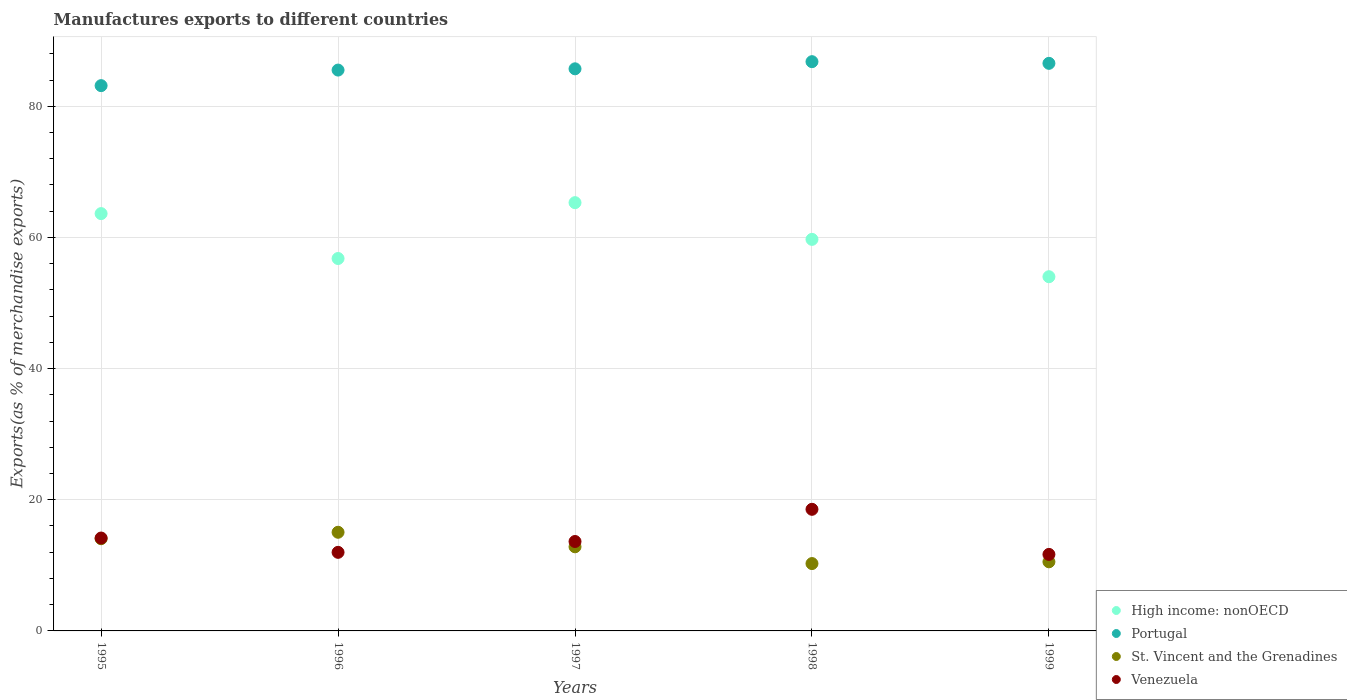How many different coloured dotlines are there?
Keep it short and to the point. 4. What is the percentage of exports to different countries in Portugal in 1998?
Give a very brief answer. 86.8. Across all years, what is the maximum percentage of exports to different countries in Venezuela?
Your answer should be compact. 18.54. Across all years, what is the minimum percentage of exports to different countries in St. Vincent and the Grenadines?
Your answer should be very brief. 10.27. In which year was the percentage of exports to different countries in Venezuela minimum?
Provide a short and direct response. 1999. What is the total percentage of exports to different countries in St. Vincent and the Grenadines in the graph?
Give a very brief answer. 62.73. What is the difference between the percentage of exports to different countries in Portugal in 1995 and that in 1996?
Provide a short and direct response. -2.37. What is the difference between the percentage of exports to different countries in St. Vincent and the Grenadines in 1995 and the percentage of exports to different countries in Portugal in 1996?
Provide a short and direct response. -71.46. What is the average percentage of exports to different countries in High income: nonOECD per year?
Offer a very short reply. 59.88. In the year 1998, what is the difference between the percentage of exports to different countries in Venezuela and percentage of exports to different countries in St. Vincent and the Grenadines?
Provide a succinct answer. 8.27. In how many years, is the percentage of exports to different countries in St. Vincent and the Grenadines greater than 40 %?
Make the answer very short. 0. What is the ratio of the percentage of exports to different countries in High income: nonOECD in 1995 to that in 1998?
Offer a very short reply. 1.07. Is the percentage of exports to different countries in Portugal in 1996 less than that in 1999?
Provide a short and direct response. Yes. What is the difference between the highest and the second highest percentage of exports to different countries in Portugal?
Your response must be concise. 0.26. What is the difference between the highest and the lowest percentage of exports to different countries in High income: nonOECD?
Your answer should be compact. 11.29. In how many years, is the percentage of exports to different countries in St. Vincent and the Grenadines greater than the average percentage of exports to different countries in St. Vincent and the Grenadines taken over all years?
Provide a short and direct response. 3. Is the sum of the percentage of exports to different countries in Portugal in 1996 and 1997 greater than the maximum percentage of exports to different countries in High income: nonOECD across all years?
Your response must be concise. Yes. Is it the case that in every year, the sum of the percentage of exports to different countries in Venezuela and percentage of exports to different countries in St. Vincent and the Grenadines  is greater than the percentage of exports to different countries in Portugal?
Your answer should be compact. No. Does the percentage of exports to different countries in Venezuela monotonically increase over the years?
Make the answer very short. No. Is the percentage of exports to different countries in St. Vincent and the Grenadines strictly less than the percentage of exports to different countries in Portugal over the years?
Your answer should be compact. Yes. How many dotlines are there?
Make the answer very short. 4. How many years are there in the graph?
Your answer should be very brief. 5. What is the title of the graph?
Offer a very short reply. Manufactures exports to different countries. Does "Myanmar" appear as one of the legend labels in the graph?
Ensure brevity in your answer.  No. What is the label or title of the X-axis?
Provide a succinct answer. Years. What is the label or title of the Y-axis?
Ensure brevity in your answer.  Exports(as % of merchandise exports). What is the Exports(as % of merchandise exports) of High income: nonOECD in 1995?
Ensure brevity in your answer.  63.63. What is the Exports(as % of merchandise exports) of Portugal in 1995?
Provide a succinct answer. 83.14. What is the Exports(as % of merchandise exports) of St. Vincent and the Grenadines in 1995?
Make the answer very short. 14.06. What is the Exports(as % of merchandise exports) in Venezuela in 1995?
Your response must be concise. 14.16. What is the Exports(as % of merchandise exports) of High income: nonOECD in 1996?
Offer a terse response. 56.78. What is the Exports(as % of merchandise exports) of Portugal in 1996?
Offer a terse response. 85.51. What is the Exports(as % of merchandise exports) of St. Vincent and the Grenadines in 1996?
Ensure brevity in your answer.  15.04. What is the Exports(as % of merchandise exports) in Venezuela in 1996?
Ensure brevity in your answer.  11.98. What is the Exports(as % of merchandise exports) of High income: nonOECD in 1997?
Your response must be concise. 65.3. What is the Exports(as % of merchandise exports) in Portugal in 1997?
Your answer should be compact. 85.71. What is the Exports(as % of merchandise exports) in St. Vincent and the Grenadines in 1997?
Provide a succinct answer. 12.83. What is the Exports(as % of merchandise exports) of Venezuela in 1997?
Keep it short and to the point. 13.64. What is the Exports(as % of merchandise exports) of High income: nonOECD in 1998?
Offer a terse response. 59.7. What is the Exports(as % of merchandise exports) of Portugal in 1998?
Provide a succinct answer. 86.8. What is the Exports(as % of merchandise exports) in St. Vincent and the Grenadines in 1998?
Give a very brief answer. 10.27. What is the Exports(as % of merchandise exports) of Venezuela in 1998?
Keep it short and to the point. 18.54. What is the Exports(as % of merchandise exports) of High income: nonOECD in 1999?
Offer a very short reply. 54.01. What is the Exports(as % of merchandise exports) of Portugal in 1999?
Provide a succinct answer. 86.54. What is the Exports(as % of merchandise exports) in St. Vincent and the Grenadines in 1999?
Offer a very short reply. 10.54. What is the Exports(as % of merchandise exports) of Venezuela in 1999?
Make the answer very short. 11.67. Across all years, what is the maximum Exports(as % of merchandise exports) in High income: nonOECD?
Keep it short and to the point. 65.3. Across all years, what is the maximum Exports(as % of merchandise exports) in Portugal?
Ensure brevity in your answer.  86.8. Across all years, what is the maximum Exports(as % of merchandise exports) of St. Vincent and the Grenadines?
Offer a very short reply. 15.04. Across all years, what is the maximum Exports(as % of merchandise exports) of Venezuela?
Your answer should be compact. 18.54. Across all years, what is the minimum Exports(as % of merchandise exports) of High income: nonOECD?
Keep it short and to the point. 54.01. Across all years, what is the minimum Exports(as % of merchandise exports) of Portugal?
Your response must be concise. 83.14. Across all years, what is the minimum Exports(as % of merchandise exports) in St. Vincent and the Grenadines?
Make the answer very short. 10.27. Across all years, what is the minimum Exports(as % of merchandise exports) in Venezuela?
Keep it short and to the point. 11.67. What is the total Exports(as % of merchandise exports) of High income: nonOECD in the graph?
Give a very brief answer. 299.42. What is the total Exports(as % of merchandise exports) of Portugal in the graph?
Make the answer very short. 427.7. What is the total Exports(as % of merchandise exports) of St. Vincent and the Grenadines in the graph?
Provide a succinct answer. 62.73. What is the total Exports(as % of merchandise exports) of Venezuela in the graph?
Offer a very short reply. 69.99. What is the difference between the Exports(as % of merchandise exports) of High income: nonOECD in 1995 and that in 1996?
Your response must be concise. 6.85. What is the difference between the Exports(as % of merchandise exports) of Portugal in 1995 and that in 1996?
Make the answer very short. -2.37. What is the difference between the Exports(as % of merchandise exports) of St. Vincent and the Grenadines in 1995 and that in 1996?
Ensure brevity in your answer.  -0.98. What is the difference between the Exports(as % of merchandise exports) in Venezuela in 1995 and that in 1996?
Give a very brief answer. 2.18. What is the difference between the Exports(as % of merchandise exports) in High income: nonOECD in 1995 and that in 1997?
Offer a terse response. -1.67. What is the difference between the Exports(as % of merchandise exports) of Portugal in 1995 and that in 1997?
Your answer should be very brief. -2.56. What is the difference between the Exports(as % of merchandise exports) of St. Vincent and the Grenadines in 1995 and that in 1997?
Keep it short and to the point. 1.23. What is the difference between the Exports(as % of merchandise exports) in Venezuela in 1995 and that in 1997?
Offer a terse response. 0.53. What is the difference between the Exports(as % of merchandise exports) of High income: nonOECD in 1995 and that in 1998?
Offer a terse response. 3.93. What is the difference between the Exports(as % of merchandise exports) in Portugal in 1995 and that in 1998?
Ensure brevity in your answer.  -3.65. What is the difference between the Exports(as % of merchandise exports) in St. Vincent and the Grenadines in 1995 and that in 1998?
Provide a succinct answer. 3.79. What is the difference between the Exports(as % of merchandise exports) in Venezuela in 1995 and that in 1998?
Your answer should be very brief. -4.38. What is the difference between the Exports(as % of merchandise exports) of High income: nonOECD in 1995 and that in 1999?
Offer a very short reply. 9.62. What is the difference between the Exports(as % of merchandise exports) of Portugal in 1995 and that in 1999?
Keep it short and to the point. -3.4. What is the difference between the Exports(as % of merchandise exports) of St. Vincent and the Grenadines in 1995 and that in 1999?
Your response must be concise. 3.52. What is the difference between the Exports(as % of merchandise exports) of Venezuela in 1995 and that in 1999?
Provide a succinct answer. 2.5. What is the difference between the Exports(as % of merchandise exports) of High income: nonOECD in 1996 and that in 1997?
Keep it short and to the point. -8.51. What is the difference between the Exports(as % of merchandise exports) in Portugal in 1996 and that in 1997?
Keep it short and to the point. -0.19. What is the difference between the Exports(as % of merchandise exports) in St. Vincent and the Grenadines in 1996 and that in 1997?
Ensure brevity in your answer.  2.22. What is the difference between the Exports(as % of merchandise exports) in Venezuela in 1996 and that in 1997?
Ensure brevity in your answer.  -1.65. What is the difference between the Exports(as % of merchandise exports) of High income: nonOECD in 1996 and that in 1998?
Keep it short and to the point. -2.92. What is the difference between the Exports(as % of merchandise exports) in Portugal in 1996 and that in 1998?
Your answer should be very brief. -1.28. What is the difference between the Exports(as % of merchandise exports) in St. Vincent and the Grenadines in 1996 and that in 1998?
Your response must be concise. 4.77. What is the difference between the Exports(as % of merchandise exports) in Venezuela in 1996 and that in 1998?
Your answer should be very brief. -6.56. What is the difference between the Exports(as % of merchandise exports) in High income: nonOECD in 1996 and that in 1999?
Your answer should be compact. 2.78. What is the difference between the Exports(as % of merchandise exports) in Portugal in 1996 and that in 1999?
Ensure brevity in your answer.  -1.03. What is the difference between the Exports(as % of merchandise exports) of St. Vincent and the Grenadines in 1996 and that in 1999?
Keep it short and to the point. 4.51. What is the difference between the Exports(as % of merchandise exports) in Venezuela in 1996 and that in 1999?
Offer a terse response. 0.31. What is the difference between the Exports(as % of merchandise exports) of High income: nonOECD in 1997 and that in 1998?
Make the answer very short. 5.6. What is the difference between the Exports(as % of merchandise exports) of Portugal in 1997 and that in 1998?
Keep it short and to the point. -1.09. What is the difference between the Exports(as % of merchandise exports) in St. Vincent and the Grenadines in 1997 and that in 1998?
Ensure brevity in your answer.  2.56. What is the difference between the Exports(as % of merchandise exports) in Venezuela in 1997 and that in 1998?
Give a very brief answer. -4.91. What is the difference between the Exports(as % of merchandise exports) in High income: nonOECD in 1997 and that in 1999?
Your answer should be compact. 11.29. What is the difference between the Exports(as % of merchandise exports) in Portugal in 1997 and that in 1999?
Offer a very short reply. -0.83. What is the difference between the Exports(as % of merchandise exports) of St. Vincent and the Grenadines in 1997 and that in 1999?
Provide a short and direct response. 2.29. What is the difference between the Exports(as % of merchandise exports) of Venezuela in 1997 and that in 1999?
Give a very brief answer. 1.97. What is the difference between the Exports(as % of merchandise exports) of High income: nonOECD in 1998 and that in 1999?
Make the answer very short. 5.69. What is the difference between the Exports(as % of merchandise exports) of Portugal in 1998 and that in 1999?
Ensure brevity in your answer.  0.26. What is the difference between the Exports(as % of merchandise exports) of St. Vincent and the Grenadines in 1998 and that in 1999?
Provide a succinct answer. -0.27. What is the difference between the Exports(as % of merchandise exports) in Venezuela in 1998 and that in 1999?
Your response must be concise. 6.88. What is the difference between the Exports(as % of merchandise exports) of High income: nonOECD in 1995 and the Exports(as % of merchandise exports) of Portugal in 1996?
Offer a terse response. -21.88. What is the difference between the Exports(as % of merchandise exports) in High income: nonOECD in 1995 and the Exports(as % of merchandise exports) in St. Vincent and the Grenadines in 1996?
Your answer should be compact. 48.59. What is the difference between the Exports(as % of merchandise exports) of High income: nonOECD in 1995 and the Exports(as % of merchandise exports) of Venezuela in 1996?
Provide a short and direct response. 51.65. What is the difference between the Exports(as % of merchandise exports) in Portugal in 1995 and the Exports(as % of merchandise exports) in St. Vincent and the Grenadines in 1996?
Offer a very short reply. 68.1. What is the difference between the Exports(as % of merchandise exports) of Portugal in 1995 and the Exports(as % of merchandise exports) of Venezuela in 1996?
Make the answer very short. 71.16. What is the difference between the Exports(as % of merchandise exports) of St. Vincent and the Grenadines in 1995 and the Exports(as % of merchandise exports) of Venezuela in 1996?
Give a very brief answer. 2.08. What is the difference between the Exports(as % of merchandise exports) in High income: nonOECD in 1995 and the Exports(as % of merchandise exports) in Portugal in 1997?
Offer a very short reply. -22.08. What is the difference between the Exports(as % of merchandise exports) of High income: nonOECD in 1995 and the Exports(as % of merchandise exports) of St. Vincent and the Grenadines in 1997?
Provide a short and direct response. 50.8. What is the difference between the Exports(as % of merchandise exports) in High income: nonOECD in 1995 and the Exports(as % of merchandise exports) in Venezuela in 1997?
Your answer should be very brief. 49.99. What is the difference between the Exports(as % of merchandise exports) in Portugal in 1995 and the Exports(as % of merchandise exports) in St. Vincent and the Grenadines in 1997?
Offer a very short reply. 70.32. What is the difference between the Exports(as % of merchandise exports) in Portugal in 1995 and the Exports(as % of merchandise exports) in Venezuela in 1997?
Make the answer very short. 69.51. What is the difference between the Exports(as % of merchandise exports) in St. Vincent and the Grenadines in 1995 and the Exports(as % of merchandise exports) in Venezuela in 1997?
Your answer should be compact. 0.42. What is the difference between the Exports(as % of merchandise exports) in High income: nonOECD in 1995 and the Exports(as % of merchandise exports) in Portugal in 1998?
Keep it short and to the point. -23.17. What is the difference between the Exports(as % of merchandise exports) of High income: nonOECD in 1995 and the Exports(as % of merchandise exports) of St. Vincent and the Grenadines in 1998?
Provide a succinct answer. 53.36. What is the difference between the Exports(as % of merchandise exports) of High income: nonOECD in 1995 and the Exports(as % of merchandise exports) of Venezuela in 1998?
Make the answer very short. 45.09. What is the difference between the Exports(as % of merchandise exports) of Portugal in 1995 and the Exports(as % of merchandise exports) of St. Vincent and the Grenadines in 1998?
Keep it short and to the point. 72.87. What is the difference between the Exports(as % of merchandise exports) in Portugal in 1995 and the Exports(as % of merchandise exports) in Venezuela in 1998?
Keep it short and to the point. 64.6. What is the difference between the Exports(as % of merchandise exports) in St. Vincent and the Grenadines in 1995 and the Exports(as % of merchandise exports) in Venezuela in 1998?
Offer a terse response. -4.49. What is the difference between the Exports(as % of merchandise exports) in High income: nonOECD in 1995 and the Exports(as % of merchandise exports) in Portugal in 1999?
Give a very brief answer. -22.91. What is the difference between the Exports(as % of merchandise exports) in High income: nonOECD in 1995 and the Exports(as % of merchandise exports) in St. Vincent and the Grenadines in 1999?
Offer a very short reply. 53.09. What is the difference between the Exports(as % of merchandise exports) of High income: nonOECD in 1995 and the Exports(as % of merchandise exports) of Venezuela in 1999?
Your answer should be very brief. 51.96. What is the difference between the Exports(as % of merchandise exports) of Portugal in 1995 and the Exports(as % of merchandise exports) of St. Vincent and the Grenadines in 1999?
Keep it short and to the point. 72.6. What is the difference between the Exports(as % of merchandise exports) of Portugal in 1995 and the Exports(as % of merchandise exports) of Venezuela in 1999?
Your response must be concise. 71.47. What is the difference between the Exports(as % of merchandise exports) in St. Vincent and the Grenadines in 1995 and the Exports(as % of merchandise exports) in Venezuela in 1999?
Keep it short and to the point. 2.39. What is the difference between the Exports(as % of merchandise exports) of High income: nonOECD in 1996 and the Exports(as % of merchandise exports) of Portugal in 1997?
Make the answer very short. -28.92. What is the difference between the Exports(as % of merchandise exports) of High income: nonOECD in 1996 and the Exports(as % of merchandise exports) of St. Vincent and the Grenadines in 1997?
Offer a terse response. 43.96. What is the difference between the Exports(as % of merchandise exports) of High income: nonOECD in 1996 and the Exports(as % of merchandise exports) of Venezuela in 1997?
Keep it short and to the point. 43.15. What is the difference between the Exports(as % of merchandise exports) in Portugal in 1996 and the Exports(as % of merchandise exports) in St. Vincent and the Grenadines in 1997?
Offer a terse response. 72.69. What is the difference between the Exports(as % of merchandise exports) in Portugal in 1996 and the Exports(as % of merchandise exports) in Venezuela in 1997?
Your answer should be compact. 71.88. What is the difference between the Exports(as % of merchandise exports) of St. Vincent and the Grenadines in 1996 and the Exports(as % of merchandise exports) of Venezuela in 1997?
Give a very brief answer. 1.41. What is the difference between the Exports(as % of merchandise exports) of High income: nonOECD in 1996 and the Exports(as % of merchandise exports) of Portugal in 1998?
Keep it short and to the point. -30.01. What is the difference between the Exports(as % of merchandise exports) in High income: nonOECD in 1996 and the Exports(as % of merchandise exports) in St. Vincent and the Grenadines in 1998?
Provide a short and direct response. 46.51. What is the difference between the Exports(as % of merchandise exports) of High income: nonOECD in 1996 and the Exports(as % of merchandise exports) of Venezuela in 1998?
Offer a terse response. 38.24. What is the difference between the Exports(as % of merchandise exports) of Portugal in 1996 and the Exports(as % of merchandise exports) of St. Vincent and the Grenadines in 1998?
Offer a terse response. 75.25. What is the difference between the Exports(as % of merchandise exports) of Portugal in 1996 and the Exports(as % of merchandise exports) of Venezuela in 1998?
Offer a terse response. 66.97. What is the difference between the Exports(as % of merchandise exports) in St. Vincent and the Grenadines in 1996 and the Exports(as % of merchandise exports) in Venezuela in 1998?
Offer a terse response. -3.5. What is the difference between the Exports(as % of merchandise exports) of High income: nonOECD in 1996 and the Exports(as % of merchandise exports) of Portugal in 1999?
Make the answer very short. -29.76. What is the difference between the Exports(as % of merchandise exports) of High income: nonOECD in 1996 and the Exports(as % of merchandise exports) of St. Vincent and the Grenadines in 1999?
Your answer should be compact. 46.25. What is the difference between the Exports(as % of merchandise exports) in High income: nonOECD in 1996 and the Exports(as % of merchandise exports) in Venezuela in 1999?
Your response must be concise. 45.12. What is the difference between the Exports(as % of merchandise exports) of Portugal in 1996 and the Exports(as % of merchandise exports) of St. Vincent and the Grenadines in 1999?
Your response must be concise. 74.98. What is the difference between the Exports(as % of merchandise exports) in Portugal in 1996 and the Exports(as % of merchandise exports) in Venezuela in 1999?
Keep it short and to the point. 73.85. What is the difference between the Exports(as % of merchandise exports) of St. Vincent and the Grenadines in 1996 and the Exports(as % of merchandise exports) of Venezuela in 1999?
Provide a succinct answer. 3.37. What is the difference between the Exports(as % of merchandise exports) in High income: nonOECD in 1997 and the Exports(as % of merchandise exports) in Portugal in 1998?
Give a very brief answer. -21.5. What is the difference between the Exports(as % of merchandise exports) in High income: nonOECD in 1997 and the Exports(as % of merchandise exports) in St. Vincent and the Grenadines in 1998?
Make the answer very short. 55.03. What is the difference between the Exports(as % of merchandise exports) in High income: nonOECD in 1997 and the Exports(as % of merchandise exports) in Venezuela in 1998?
Provide a short and direct response. 46.76. What is the difference between the Exports(as % of merchandise exports) of Portugal in 1997 and the Exports(as % of merchandise exports) of St. Vincent and the Grenadines in 1998?
Ensure brevity in your answer.  75.44. What is the difference between the Exports(as % of merchandise exports) in Portugal in 1997 and the Exports(as % of merchandise exports) in Venezuela in 1998?
Offer a terse response. 67.16. What is the difference between the Exports(as % of merchandise exports) in St. Vincent and the Grenadines in 1997 and the Exports(as % of merchandise exports) in Venezuela in 1998?
Your response must be concise. -5.72. What is the difference between the Exports(as % of merchandise exports) in High income: nonOECD in 1997 and the Exports(as % of merchandise exports) in Portugal in 1999?
Your answer should be compact. -21.24. What is the difference between the Exports(as % of merchandise exports) of High income: nonOECD in 1997 and the Exports(as % of merchandise exports) of St. Vincent and the Grenadines in 1999?
Keep it short and to the point. 54.76. What is the difference between the Exports(as % of merchandise exports) in High income: nonOECD in 1997 and the Exports(as % of merchandise exports) in Venezuela in 1999?
Your answer should be very brief. 53.63. What is the difference between the Exports(as % of merchandise exports) of Portugal in 1997 and the Exports(as % of merchandise exports) of St. Vincent and the Grenadines in 1999?
Offer a terse response. 75.17. What is the difference between the Exports(as % of merchandise exports) in Portugal in 1997 and the Exports(as % of merchandise exports) in Venezuela in 1999?
Provide a succinct answer. 74.04. What is the difference between the Exports(as % of merchandise exports) in St. Vincent and the Grenadines in 1997 and the Exports(as % of merchandise exports) in Venezuela in 1999?
Ensure brevity in your answer.  1.16. What is the difference between the Exports(as % of merchandise exports) in High income: nonOECD in 1998 and the Exports(as % of merchandise exports) in Portugal in 1999?
Your response must be concise. -26.84. What is the difference between the Exports(as % of merchandise exports) of High income: nonOECD in 1998 and the Exports(as % of merchandise exports) of St. Vincent and the Grenadines in 1999?
Ensure brevity in your answer.  49.16. What is the difference between the Exports(as % of merchandise exports) of High income: nonOECD in 1998 and the Exports(as % of merchandise exports) of Venezuela in 1999?
Keep it short and to the point. 48.03. What is the difference between the Exports(as % of merchandise exports) in Portugal in 1998 and the Exports(as % of merchandise exports) in St. Vincent and the Grenadines in 1999?
Ensure brevity in your answer.  76.26. What is the difference between the Exports(as % of merchandise exports) of Portugal in 1998 and the Exports(as % of merchandise exports) of Venezuela in 1999?
Your answer should be compact. 75.13. What is the difference between the Exports(as % of merchandise exports) in St. Vincent and the Grenadines in 1998 and the Exports(as % of merchandise exports) in Venezuela in 1999?
Keep it short and to the point. -1.4. What is the average Exports(as % of merchandise exports) of High income: nonOECD per year?
Offer a terse response. 59.88. What is the average Exports(as % of merchandise exports) of Portugal per year?
Your answer should be very brief. 85.54. What is the average Exports(as % of merchandise exports) in St. Vincent and the Grenadines per year?
Provide a short and direct response. 12.55. What is the average Exports(as % of merchandise exports) in Venezuela per year?
Offer a terse response. 14. In the year 1995, what is the difference between the Exports(as % of merchandise exports) in High income: nonOECD and Exports(as % of merchandise exports) in Portugal?
Give a very brief answer. -19.51. In the year 1995, what is the difference between the Exports(as % of merchandise exports) of High income: nonOECD and Exports(as % of merchandise exports) of St. Vincent and the Grenadines?
Keep it short and to the point. 49.57. In the year 1995, what is the difference between the Exports(as % of merchandise exports) of High income: nonOECD and Exports(as % of merchandise exports) of Venezuela?
Provide a succinct answer. 49.47. In the year 1995, what is the difference between the Exports(as % of merchandise exports) of Portugal and Exports(as % of merchandise exports) of St. Vincent and the Grenadines?
Offer a terse response. 69.08. In the year 1995, what is the difference between the Exports(as % of merchandise exports) in Portugal and Exports(as % of merchandise exports) in Venezuela?
Give a very brief answer. 68.98. In the year 1995, what is the difference between the Exports(as % of merchandise exports) of St. Vincent and the Grenadines and Exports(as % of merchandise exports) of Venezuela?
Offer a terse response. -0.11. In the year 1996, what is the difference between the Exports(as % of merchandise exports) of High income: nonOECD and Exports(as % of merchandise exports) of Portugal?
Provide a short and direct response. -28.73. In the year 1996, what is the difference between the Exports(as % of merchandise exports) of High income: nonOECD and Exports(as % of merchandise exports) of St. Vincent and the Grenadines?
Keep it short and to the point. 41.74. In the year 1996, what is the difference between the Exports(as % of merchandise exports) of High income: nonOECD and Exports(as % of merchandise exports) of Venezuela?
Your answer should be very brief. 44.8. In the year 1996, what is the difference between the Exports(as % of merchandise exports) in Portugal and Exports(as % of merchandise exports) in St. Vincent and the Grenadines?
Your answer should be compact. 70.47. In the year 1996, what is the difference between the Exports(as % of merchandise exports) in Portugal and Exports(as % of merchandise exports) in Venezuela?
Offer a very short reply. 73.53. In the year 1996, what is the difference between the Exports(as % of merchandise exports) in St. Vincent and the Grenadines and Exports(as % of merchandise exports) in Venezuela?
Make the answer very short. 3.06. In the year 1997, what is the difference between the Exports(as % of merchandise exports) in High income: nonOECD and Exports(as % of merchandise exports) in Portugal?
Your answer should be very brief. -20.41. In the year 1997, what is the difference between the Exports(as % of merchandise exports) in High income: nonOECD and Exports(as % of merchandise exports) in St. Vincent and the Grenadines?
Make the answer very short. 52.47. In the year 1997, what is the difference between the Exports(as % of merchandise exports) of High income: nonOECD and Exports(as % of merchandise exports) of Venezuela?
Offer a terse response. 51.66. In the year 1997, what is the difference between the Exports(as % of merchandise exports) of Portugal and Exports(as % of merchandise exports) of St. Vincent and the Grenadines?
Provide a succinct answer. 72.88. In the year 1997, what is the difference between the Exports(as % of merchandise exports) in Portugal and Exports(as % of merchandise exports) in Venezuela?
Your response must be concise. 72.07. In the year 1997, what is the difference between the Exports(as % of merchandise exports) of St. Vincent and the Grenadines and Exports(as % of merchandise exports) of Venezuela?
Make the answer very short. -0.81. In the year 1998, what is the difference between the Exports(as % of merchandise exports) in High income: nonOECD and Exports(as % of merchandise exports) in Portugal?
Provide a succinct answer. -27.1. In the year 1998, what is the difference between the Exports(as % of merchandise exports) in High income: nonOECD and Exports(as % of merchandise exports) in St. Vincent and the Grenadines?
Your answer should be compact. 49.43. In the year 1998, what is the difference between the Exports(as % of merchandise exports) in High income: nonOECD and Exports(as % of merchandise exports) in Venezuela?
Offer a very short reply. 41.16. In the year 1998, what is the difference between the Exports(as % of merchandise exports) in Portugal and Exports(as % of merchandise exports) in St. Vincent and the Grenadines?
Make the answer very short. 76.53. In the year 1998, what is the difference between the Exports(as % of merchandise exports) of Portugal and Exports(as % of merchandise exports) of Venezuela?
Provide a succinct answer. 68.25. In the year 1998, what is the difference between the Exports(as % of merchandise exports) in St. Vincent and the Grenadines and Exports(as % of merchandise exports) in Venezuela?
Provide a short and direct response. -8.27. In the year 1999, what is the difference between the Exports(as % of merchandise exports) in High income: nonOECD and Exports(as % of merchandise exports) in Portugal?
Make the answer very short. -32.53. In the year 1999, what is the difference between the Exports(as % of merchandise exports) of High income: nonOECD and Exports(as % of merchandise exports) of St. Vincent and the Grenadines?
Offer a terse response. 43.47. In the year 1999, what is the difference between the Exports(as % of merchandise exports) in High income: nonOECD and Exports(as % of merchandise exports) in Venezuela?
Your answer should be very brief. 42.34. In the year 1999, what is the difference between the Exports(as % of merchandise exports) of Portugal and Exports(as % of merchandise exports) of St. Vincent and the Grenadines?
Offer a terse response. 76. In the year 1999, what is the difference between the Exports(as % of merchandise exports) of Portugal and Exports(as % of merchandise exports) of Venezuela?
Offer a terse response. 74.87. In the year 1999, what is the difference between the Exports(as % of merchandise exports) of St. Vincent and the Grenadines and Exports(as % of merchandise exports) of Venezuela?
Keep it short and to the point. -1.13. What is the ratio of the Exports(as % of merchandise exports) in High income: nonOECD in 1995 to that in 1996?
Give a very brief answer. 1.12. What is the ratio of the Exports(as % of merchandise exports) of Portugal in 1995 to that in 1996?
Make the answer very short. 0.97. What is the ratio of the Exports(as % of merchandise exports) in St. Vincent and the Grenadines in 1995 to that in 1996?
Provide a short and direct response. 0.93. What is the ratio of the Exports(as % of merchandise exports) in Venezuela in 1995 to that in 1996?
Offer a terse response. 1.18. What is the ratio of the Exports(as % of merchandise exports) of High income: nonOECD in 1995 to that in 1997?
Ensure brevity in your answer.  0.97. What is the ratio of the Exports(as % of merchandise exports) in Portugal in 1995 to that in 1997?
Ensure brevity in your answer.  0.97. What is the ratio of the Exports(as % of merchandise exports) of St. Vincent and the Grenadines in 1995 to that in 1997?
Give a very brief answer. 1.1. What is the ratio of the Exports(as % of merchandise exports) of Venezuela in 1995 to that in 1997?
Provide a succinct answer. 1.04. What is the ratio of the Exports(as % of merchandise exports) of High income: nonOECD in 1995 to that in 1998?
Make the answer very short. 1.07. What is the ratio of the Exports(as % of merchandise exports) of Portugal in 1995 to that in 1998?
Your answer should be compact. 0.96. What is the ratio of the Exports(as % of merchandise exports) in St. Vincent and the Grenadines in 1995 to that in 1998?
Provide a short and direct response. 1.37. What is the ratio of the Exports(as % of merchandise exports) in Venezuela in 1995 to that in 1998?
Offer a very short reply. 0.76. What is the ratio of the Exports(as % of merchandise exports) of High income: nonOECD in 1995 to that in 1999?
Your answer should be very brief. 1.18. What is the ratio of the Exports(as % of merchandise exports) in Portugal in 1995 to that in 1999?
Your answer should be very brief. 0.96. What is the ratio of the Exports(as % of merchandise exports) of St. Vincent and the Grenadines in 1995 to that in 1999?
Your response must be concise. 1.33. What is the ratio of the Exports(as % of merchandise exports) in Venezuela in 1995 to that in 1999?
Your answer should be very brief. 1.21. What is the ratio of the Exports(as % of merchandise exports) in High income: nonOECD in 1996 to that in 1997?
Your answer should be very brief. 0.87. What is the ratio of the Exports(as % of merchandise exports) of Portugal in 1996 to that in 1997?
Provide a succinct answer. 1. What is the ratio of the Exports(as % of merchandise exports) in St. Vincent and the Grenadines in 1996 to that in 1997?
Your answer should be compact. 1.17. What is the ratio of the Exports(as % of merchandise exports) of Venezuela in 1996 to that in 1997?
Make the answer very short. 0.88. What is the ratio of the Exports(as % of merchandise exports) of High income: nonOECD in 1996 to that in 1998?
Your answer should be very brief. 0.95. What is the ratio of the Exports(as % of merchandise exports) of Portugal in 1996 to that in 1998?
Your response must be concise. 0.99. What is the ratio of the Exports(as % of merchandise exports) of St. Vincent and the Grenadines in 1996 to that in 1998?
Give a very brief answer. 1.46. What is the ratio of the Exports(as % of merchandise exports) in Venezuela in 1996 to that in 1998?
Provide a succinct answer. 0.65. What is the ratio of the Exports(as % of merchandise exports) in High income: nonOECD in 1996 to that in 1999?
Provide a succinct answer. 1.05. What is the ratio of the Exports(as % of merchandise exports) in Portugal in 1996 to that in 1999?
Provide a succinct answer. 0.99. What is the ratio of the Exports(as % of merchandise exports) of St. Vincent and the Grenadines in 1996 to that in 1999?
Offer a very short reply. 1.43. What is the ratio of the Exports(as % of merchandise exports) in Venezuela in 1996 to that in 1999?
Provide a short and direct response. 1.03. What is the ratio of the Exports(as % of merchandise exports) in High income: nonOECD in 1997 to that in 1998?
Your response must be concise. 1.09. What is the ratio of the Exports(as % of merchandise exports) of Portugal in 1997 to that in 1998?
Offer a terse response. 0.99. What is the ratio of the Exports(as % of merchandise exports) of St. Vincent and the Grenadines in 1997 to that in 1998?
Provide a succinct answer. 1.25. What is the ratio of the Exports(as % of merchandise exports) in Venezuela in 1997 to that in 1998?
Your answer should be compact. 0.74. What is the ratio of the Exports(as % of merchandise exports) of High income: nonOECD in 1997 to that in 1999?
Provide a short and direct response. 1.21. What is the ratio of the Exports(as % of merchandise exports) of Portugal in 1997 to that in 1999?
Offer a very short reply. 0.99. What is the ratio of the Exports(as % of merchandise exports) in St. Vincent and the Grenadines in 1997 to that in 1999?
Give a very brief answer. 1.22. What is the ratio of the Exports(as % of merchandise exports) in Venezuela in 1997 to that in 1999?
Offer a very short reply. 1.17. What is the ratio of the Exports(as % of merchandise exports) in High income: nonOECD in 1998 to that in 1999?
Keep it short and to the point. 1.11. What is the ratio of the Exports(as % of merchandise exports) in St. Vincent and the Grenadines in 1998 to that in 1999?
Your answer should be compact. 0.97. What is the ratio of the Exports(as % of merchandise exports) of Venezuela in 1998 to that in 1999?
Offer a very short reply. 1.59. What is the difference between the highest and the second highest Exports(as % of merchandise exports) of High income: nonOECD?
Your answer should be compact. 1.67. What is the difference between the highest and the second highest Exports(as % of merchandise exports) in Portugal?
Your response must be concise. 0.26. What is the difference between the highest and the second highest Exports(as % of merchandise exports) of St. Vincent and the Grenadines?
Provide a succinct answer. 0.98. What is the difference between the highest and the second highest Exports(as % of merchandise exports) of Venezuela?
Your answer should be very brief. 4.38. What is the difference between the highest and the lowest Exports(as % of merchandise exports) of High income: nonOECD?
Provide a succinct answer. 11.29. What is the difference between the highest and the lowest Exports(as % of merchandise exports) of Portugal?
Ensure brevity in your answer.  3.65. What is the difference between the highest and the lowest Exports(as % of merchandise exports) in St. Vincent and the Grenadines?
Make the answer very short. 4.77. What is the difference between the highest and the lowest Exports(as % of merchandise exports) of Venezuela?
Offer a very short reply. 6.88. 